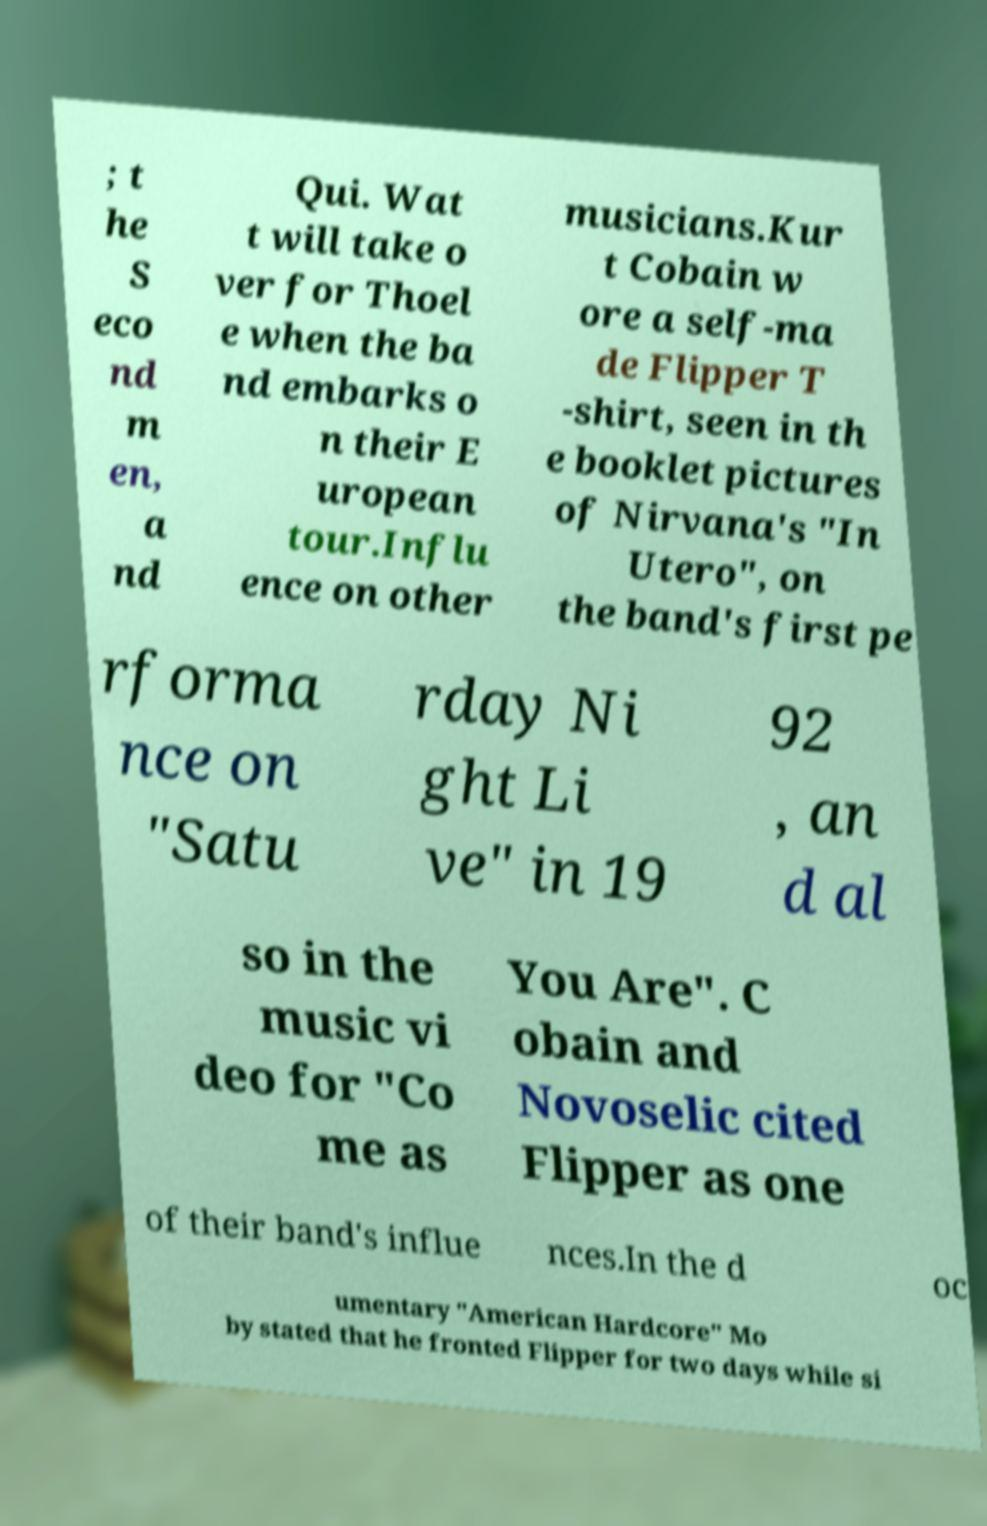There's text embedded in this image that I need extracted. Can you transcribe it verbatim? ; t he S eco nd m en, a nd Qui. Wat t will take o ver for Thoel e when the ba nd embarks o n their E uropean tour.Influ ence on other musicians.Kur t Cobain w ore a self-ma de Flipper T -shirt, seen in th e booklet pictures of Nirvana's "In Utero", on the band's first pe rforma nce on "Satu rday Ni ght Li ve" in 19 92 , an d al so in the music vi deo for "Co me as You Are". C obain and Novoselic cited Flipper as one of their band's influe nces.In the d oc umentary "American Hardcore" Mo by stated that he fronted Flipper for two days while si 